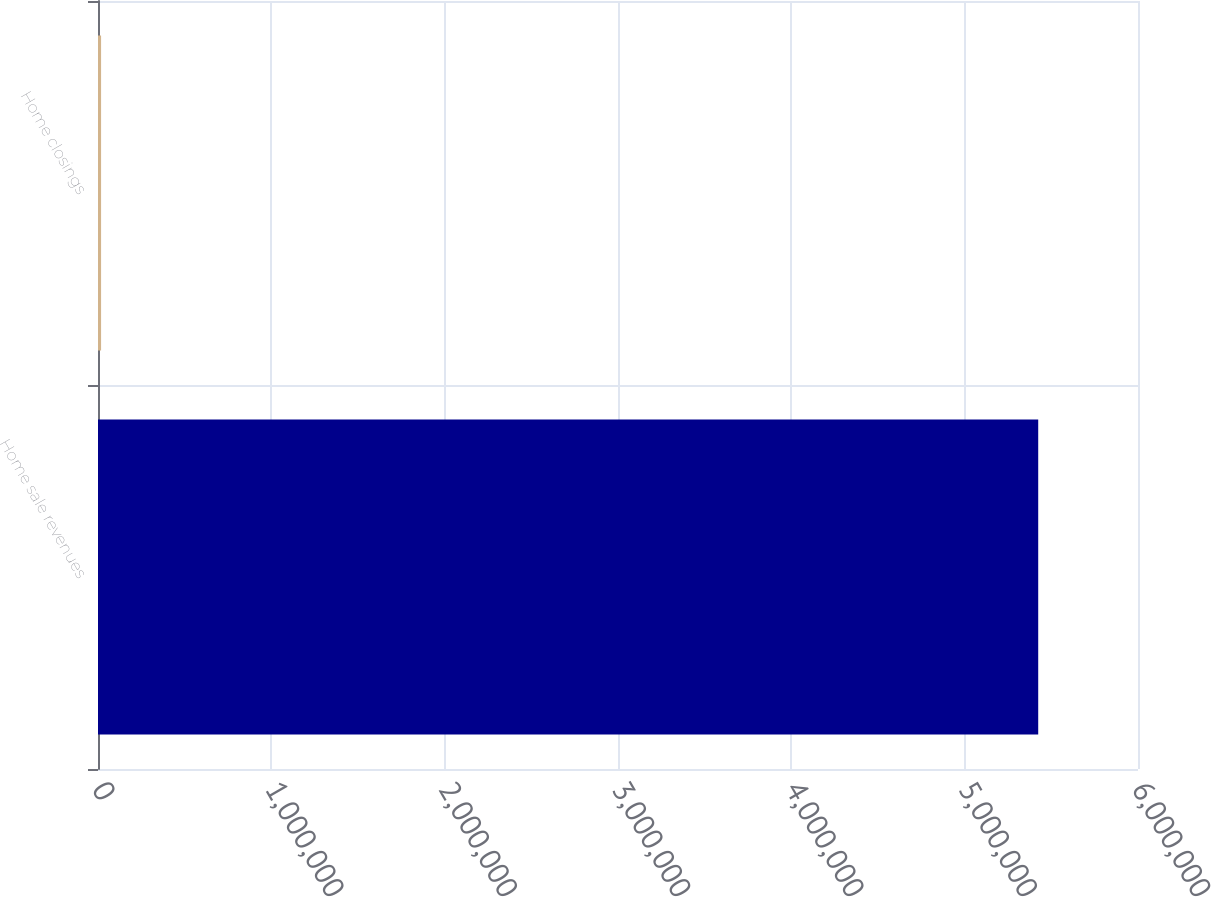Convert chart to OTSL. <chart><loc_0><loc_0><loc_500><loc_500><bar_chart><fcel>Home sale revenues<fcel>Home closings<nl><fcel>5.42431e+06<fcel>17766<nl></chart> 